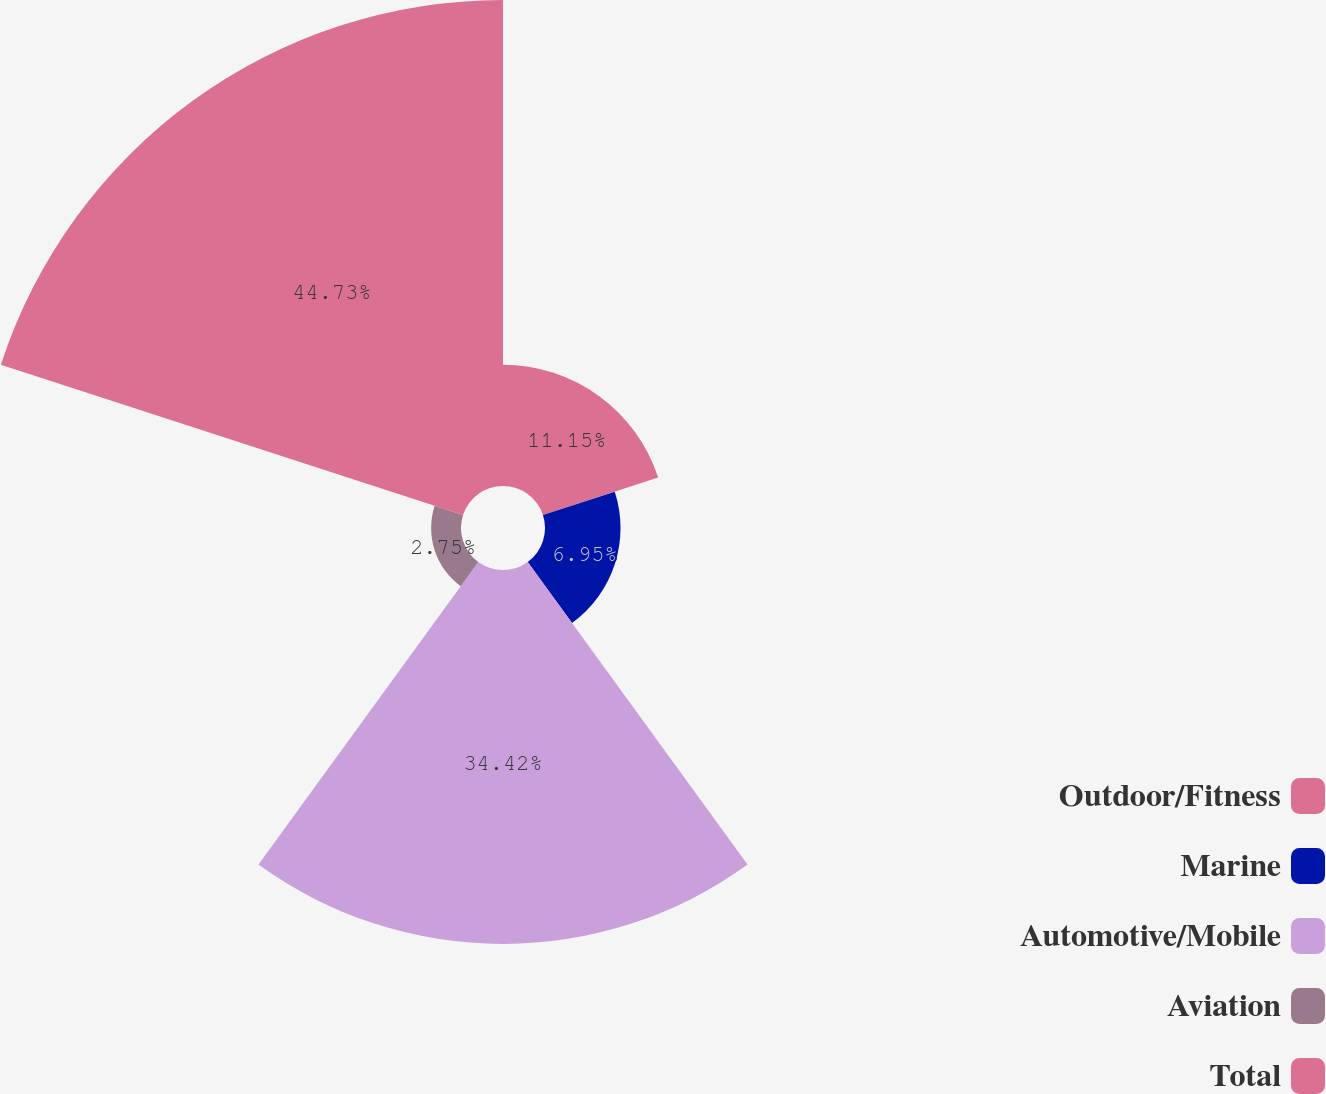Convert chart. <chart><loc_0><loc_0><loc_500><loc_500><pie_chart><fcel>Outdoor/Fitness<fcel>Marine<fcel>Automotive/Mobile<fcel>Aviation<fcel>Total<nl><fcel>11.15%<fcel>6.95%<fcel>34.42%<fcel>2.75%<fcel>44.73%<nl></chart> 